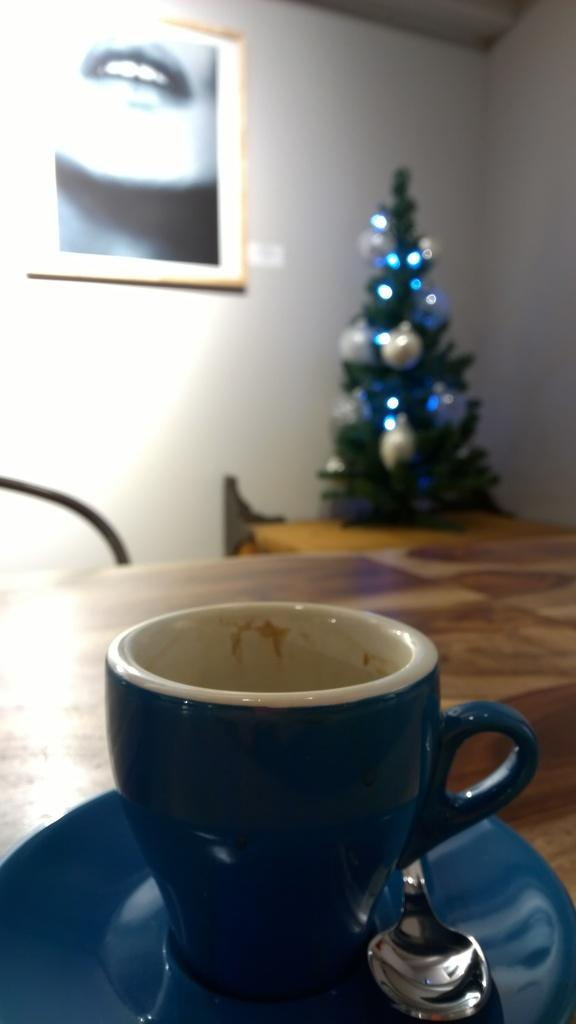What is on the table in the image? There is a cup, a saucer, and a spoon on the table in the image. What can be seen on the wall in the image? There is a frame on the wall in the image. What is the seasonal decoration present in the image? There is a Christmas tree in the image. What is the background of the image? There is a wall visible in the image. What type of locket is hanging from the Christmas tree in the image? There is no locket hanging from the Christmas tree in the image. What team is playing on the wall in the image? There is no team playing on the wall in the image; there is only a frame visible. 